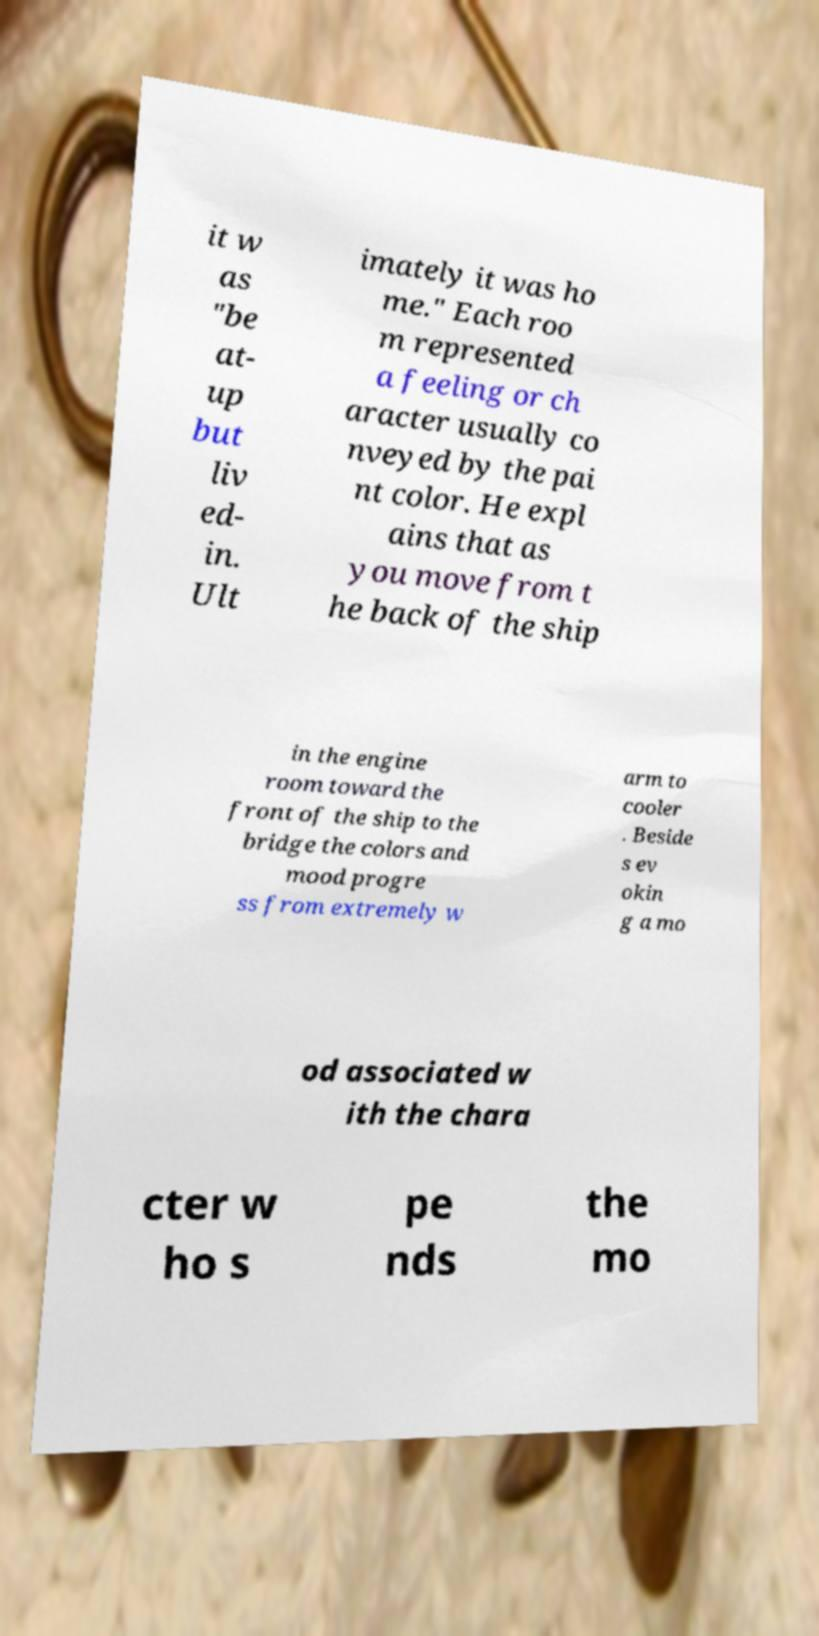I need the written content from this picture converted into text. Can you do that? it w as "be at- up but liv ed- in. Ult imately it was ho me." Each roo m represented a feeling or ch aracter usually co nveyed by the pai nt color. He expl ains that as you move from t he back of the ship in the engine room toward the front of the ship to the bridge the colors and mood progre ss from extremely w arm to cooler . Beside s ev okin g a mo od associated w ith the chara cter w ho s pe nds the mo 